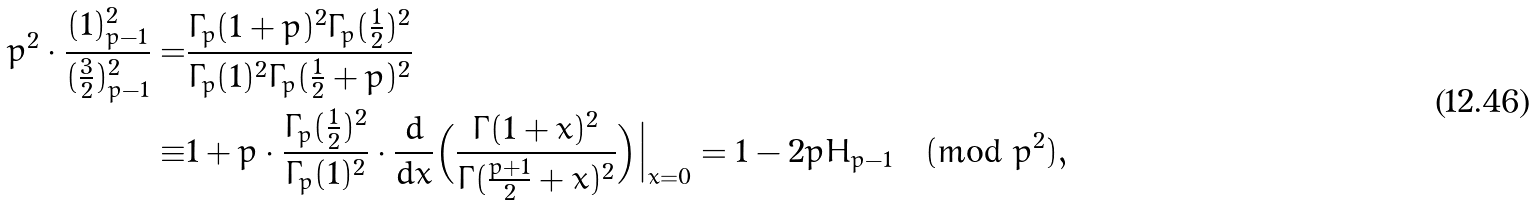<formula> <loc_0><loc_0><loc_500><loc_500>p ^ { 2 } \cdot \frac { ( 1 ) _ { p - 1 } ^ { 2 } } { ( \frac { 3 } { 2 } ) _ { p - 1 } ^ { 2 } } = & \frac { \Gamma _ { p } ( 1 + p ) ^ { 2 } \Gamma _ { p } ( \frac { 1 } { 2 } ) ^ { 2 } } { \Gamma _ { p } ( 1 ) ^ { 2 } \Gamma _ { p } ( \frac { 1 } { 2 } + p ) ^ { 2 } } \\ \equiv & 1 + p \cdot \frac { \Gamma _ { p } ( \frac { 1 } { 2 } ) ^ { 2 } } { \Gamma _ { p } ( 1 ) ^ { 2 } } \cdot \frac { d } { d x } \Big ( \frac { \Gamma ( 1 + x ) ^ { 2 } } { \Gamma ( \frac { p + 1 } { 2 } + x ) ^ { 2 } } \Big ) \Big | _ { x = 0 } = 1 - 2 p H _ { p - 1 } \pmod { p ^ { 2 } } ,</formula> 